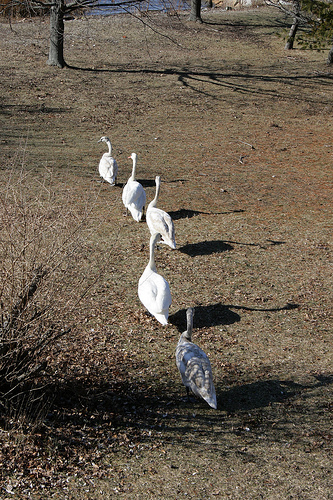<image>
Can you confirm if the feather is on the bird? No. The feather is not positioned on the bird. They may be near each other, but the feather is not supported by or resting on top of the bird. 